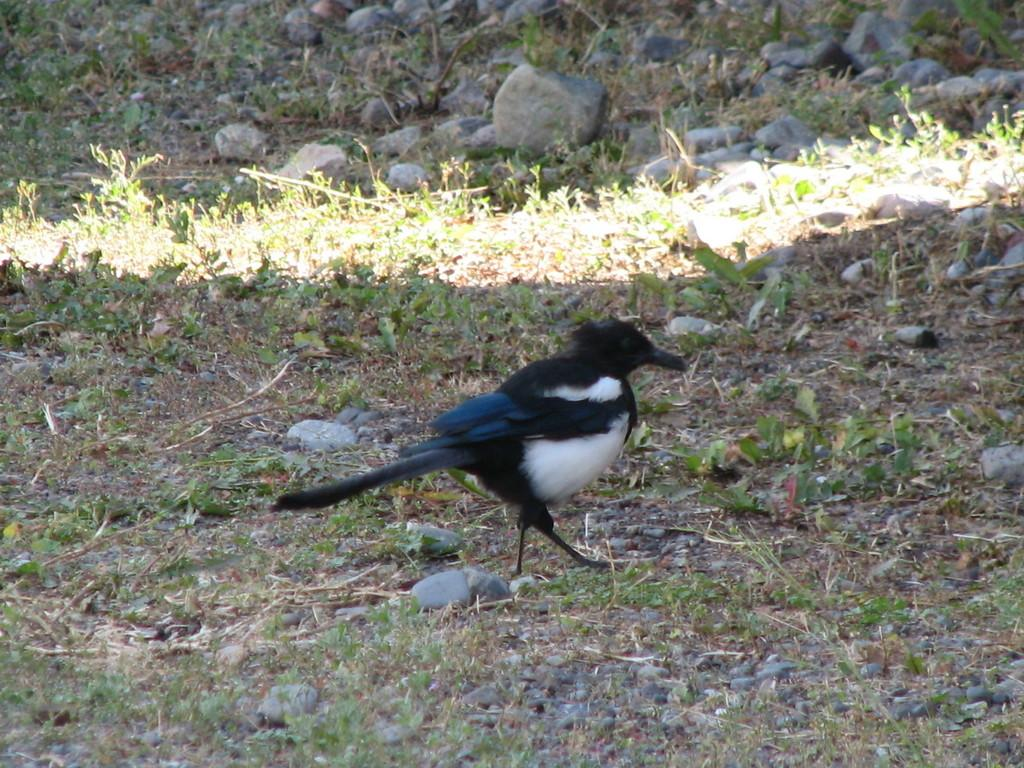What is the main subject in the center of the image? There is a bird in the center of the image. What colors are present on the bird? The bird is black and white in color. What type of objects can be seen at the top side of the image? There are pebbles at the top side of the image. How does the bird use the comb in the image? There is no comb present in the image; the bird is black and white in color. 